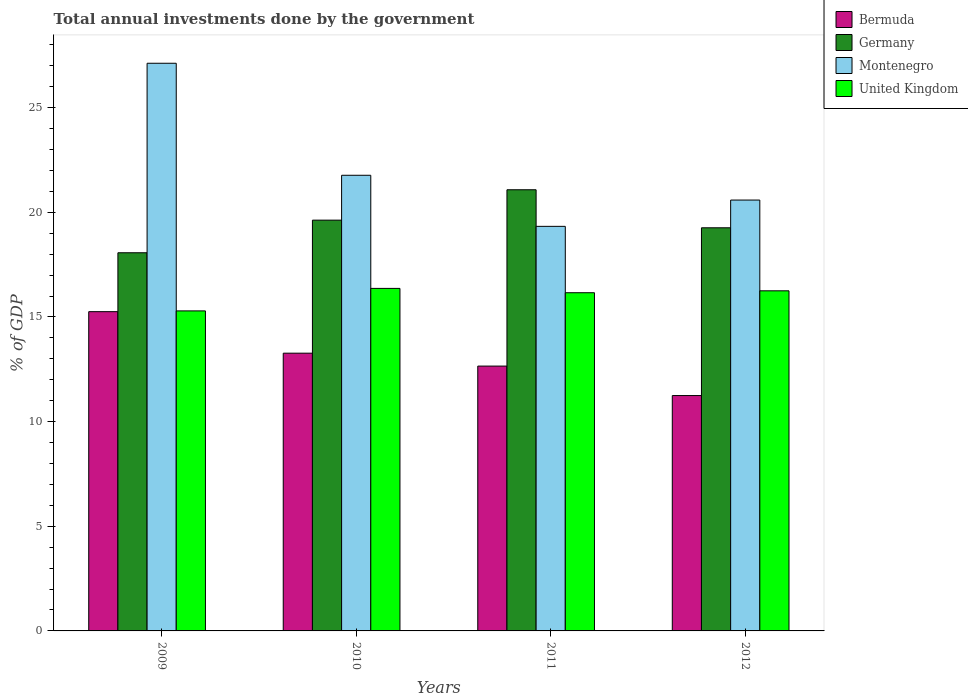How many different coloured bars are there?
Offer a very short reply. 4. How many groups of bars are there?
Provide a succinct answer. 4. Are the number of bars per tick equal to the number of legend labels?
Your response must be concise. Yes. Are the number of bars on each tick of the X-axis equal?
Ensure brevity in your answer.  Yes. How many bars are there on the 4th tick from the left?
Your response must be concise. 4. How many bars are there on the 1st tick from the right?
Your answer should be compact. 4. What is the label of the 2nd group of bars from the left?
Make the answer very short. 2010. In how many cases, is the number of bars for a given year not equal to the number of legend labels?
Keep it short and to the point. 0. What is the total annual investments done by the government in Bermuda in 2010?
Your answer should be very brief. 13.27. Across all years, what is the maximum total annual investments done by the government in Germany?
Your answer should be very brief. 21.08. Across all years, what is the minimum total annual investments done by the government in Montenegro?
Give a very brief answer. 19.33. In which year was the total annual investments done by the government in United Kingdom maximum?
Keep it short and to the point. 2010. In which year was the total annual investments done by the government in United Kingdom minimum?
Ensure brevity in your answer.  2009. What is the total total annual investments done by the government in Bermuda in the graph?
Your answer should be compact. 52.42. What is the difference between the total annual investments done by the government in Bermuda in 2010 and that in 2011?
Keep it short and to the point. 0.62. What is the difference between the total annual investments done by the government in Montenegro in 2010 and the total annual investments done by the government in United Kingdom in 2009?
Offer a very short reply. 6.48. What is the average total annual investments done by the government in United Kingdom per year?
Give a very brief answer. 16.02. In the year 2009, what is the difference between the total annual investments done by the government in Germany and total annual investments done by the government in Montenegro?
Your answer should be very brief. -9.05. What is the ratio of the total annual investments done by the government in Germany in 2010 to that in 2011?
Offer a very short reply. 0.93. What is the difference between the highest and the second highest total annual investments done by the government in Germany?
Make the answer very short. 1.45. What is the difference between the highest and the lowest total annual investments done by the government in United Kingdom?
Provide a succinct answer. 1.07. In how many years, is the total annual investments done by the government in Montenegro greater than the average total annual investments done by the government in Montenegro taken over all years?
Offer a terse response. 1. Is the sum of the total annual investments done by the government in Bermuda in 2011 and 2012 greater than the maximum total annual investments done by the government in Montenegro across all years?
Ensure brevity in your answer.  No. What does the 4th bar from the right in 2012 represents?
Make the answer very short. Bermuda. How many bars are there?
Keep it short and to the point. 16. Are all the bars in the graph horizontal?
Ensure brevity in your answer.  No. Are the values on the major ticks of Y-axis written in scientific E-notation?
Offer a terse response. No. Where does the legend appear in the graph?
Offer a terse response. Top right. What is the title of the graph?
Provide a succinct answer. Total annual investments done by the government. Does "Papua New Guinea" appear as one of the legend labels in the graph?
Make the answer very short. No. What is the label or title of the X-axis?
Offer a very short reply. Years. What is the label or title of the Y-axis?
Offer a very short reply. % of GDP. What is the % of GDP in Bermuda in 2009?
Offer a terse response. 15.25. What is the % of GDP in Germany in 2009?
Keep it short and to the point. 18.07. What is the % of GDP in Montenegro in 2009?
Provide a short and direct response. 27.12. What is the % of GDP of United Kingdom in 2009?
Make the answer very short. 15.29. What is the % of GDP of Bermuda in 2010?
Provide a short and direct response. 13.27. What is the % of GDP of Germany in 2010?
Your response must be concise. 19.63. What is the % of GDP in Montenegro in 2010?
Give a very brief answer. 21.77. What is the % of GDP of United Kingdom in 2010?
Your answer should be very brief. 16.36. What is the % of GDP of Bermuda in 2011?
Your answer should be very brief. 12.65. What is the % of GDP of Germany in 2011?
Give a very brief answer. 21.08. What is the % of GDP of Montenegro in 2011?
Give a very brief answer. 19.33. What is the % of GDP of United Kingdom in 2011?
Offer a terse response. 16.16. What is the % of GDP of Bermuda in 2012?
Your answer should be very brief. 11.25. What is the % of GDP in Germany in 2012?
Provide a succinct answer. 19.26. What is the % of GDP in Montenegro in 2012?
Ensure brevity in your answer.  20.59. What is the % of GDP of United Kingdom in 2012?
Give a very brief answer. 16.25. Across all years, what is the maximum % of GDP of Bermuda?
Give a very brief answer. 15.25. Across all years, what is the maximum % of GDP in Germany?
Provide a short and direct response. 21.08. Across all years, what is the maximum % of GDP in Montenegro?
Your response must be concise. 27.12. Across all years, what is the maximum % of GDP in United Kingdom?
Offer a terse response. 16.36. Across all years, what is the minimum % of GDP of Bermuda?
Provide a short and direct response. 11.25. Across all years, what is the minimum % of GDP in Germany?
Offer a terse response. 18.07. Across all years, what is the minimum % of GDP in Montenegro?
Your response must be concise. 19.33. Across all years, what is the minimum % of GDP in United Kingdom?
Provide a succinct answer. 15.29. What is the total % of GDP in Bermuda in the graph?
Your response must be concise. 52.42. What is the total % of GDP in Germany in the graph?
Provide a short and direct response. 78.03. What is the total % of GDP of Montenegro in the graph?
Offer a very short reply. 88.81. What is the total % of GDP in United Kingdom in the graph?
Provide a short and direct response. 64.06. What is the difference between the % of GDP of Bermuda in 2009 and that in 2010?
Offer a terse response. 1.98. What is the difference between the % of GDP of Germany in 2009 and that in 2010?
Your answer should be very brief. -1.56. What is the difference between the % of GDP in Montenegro in 2009 and that in 2010?
Your response must be concise. 5.35. What is the difference between the % of GDP in United Kingdom in 2009 and that in 2010?
Make the answer very short. -1.07. What is the difference between the % of GDP of Bermuda in 2009 and that in 2011?
Offer a terse response. 2.6. What is the difference between the % of GDP of Germany in 2009 and that in 2011?
Ensure brevity in your answer.  -3.01. What is the difference between the % of GDP in Montenegro in 2009 and that in 2011?
Make the answer very short. 7.79. What is the difference between the % of GDP in United Kingdom in 2009 and that in 2011?
Your answer should be very brief. -0.87. What is the difference between the % of GDP of Bermuda in 2009 and that in 2012?
Offer a very short reply. 4.01. What is the difference between the % of GDP of Germany in 2009 and that in 2012?
Your response must be concise. -1.19. What is the difference between the % of GDP in Montenegro in 2009 and that in 2012?
Offer a very short reply. 6.54. What is the difference between the % of GDP of United Kingdom in 2009 and that in 2012?
Keep it short and to the point. -0.96. What is the difference between the % of GDP of Bermuda in 2010 and that in 2011?
Your answer should be compact. 0.62. What is the difference between the % of GDP in Germany in 2010 and that in 2011?
Offer a terse response. -1.45. What is the difference between the % of GDP of Montenegro in 2010 and that in 2011?
Provide a short and direct response. 2.44. What is the difference between the % of GDP in United Kingdom in 2010 and that in 2011?
Give a very brief answer. 0.21. What is the difference between the % of GDP in Bermuda in 2010 and that in 2012?
Your answer should be very brief. 2.02. What is the difference between the % of GDP in Germany in 2010 and that in 2012?
Provide a succinct answer. 0.36. What is the difference between the % of GDP in Montenegro in 2010 and that in 2012?
Keep it short and to the point. 1.18. What is the difference between the % of GDP of United Kingdom in 2010 and that in 2012?
Your answer should be compact. 0.12. What is the difference between the % of GDP of Bermuda in 2011 and that in 2012?
Keep it short and to the point. 1.41. What is the difference between the % of GDP in Germany in 2011 and that in 2012?
Provide a short and direct response. 1.82. What is the difference between the % of GDP of Montenegro in 2011 and that in 2012?
Your response must be concise. -1.26. What is the difference between the % of GDP of United Kingdom in 2011 and that in 2012?
Provide a succinct answer. -0.09. What is the difference between the % of GDP of Bermuda in 2009 and the % of GDP of Germany in 2010?
Your answer should be compact. -4.37. What is the difference between the % of GDP in Bermuda in 2009 and the % of GDP in Montenegro in 2010?
Make the answer very short. -6.52. What is the difference between the % of GDP of Bermuda in 2009 and the % of GDP of United Kingdom in 2010?
Your answer should be very brief. -1.11. What is the difference between the % of GDP of Germany in 2009 and the % of GDP of Montenegro in 2010?
Offer a very short reply. -3.7. What is the difference between the % of GDP in Germany in 2009 and the % of GDP in United Kingdom in 2010?
Your answer should be very brief. 1.7. What is the difference between the % of GDP in Montenegro in 2009 and the % of GDP in United Kingdom in 2010?
Ensure brevity in your answer.  10.76. What is the difference between the % of GDP of Bermuda in 2009 and the % of GDP of Germany in 2011?
Provide a short and direct response. -5.82. What is the difference between the % of GDP of Bermuda in 2009 and the % of GDP of Montenegro in 2011?
Provide a short and direct response. -4.08. What is the difference between the % of GDP in Bermuda in 2009 and the % of GDP in United Kingdom in 2011?
Make the answer very short. -0.9. What is the difference between the % of GDP of Germany in 2009 and the % of GDP of Montenegro in 2011?
Offer a terse response. -1.26. What is the difference between the % of GDP of Germany in 2009 and the % of GDP of United Kingdom in 2011?
Your answer should be compact. 1.91. What is the difference between the % of GDP in Montenegro in 2009 and the % of GDP in United Kingdom in 2011?
Ensure brevity in your answer.  10.96. What is the difference between the % of GDP in Bermuda in 2009 and the % of GDP in Germany in 2012?
Your answer should be very brief. -4.01. What is the difference between the % of GDP of Bermuda in 2009 and the % of GDP of Montenegro in 2012?
Offer a terse response. -5.33. What is the difference between the % of GDP in Bermuda in 2009 and the % of GDP in United Kingdom in 2012?
Your answer should be very brief. -1. What is the difference between the % of GDP of Germany in 2009 and the % of GDP of Montenegro in 2012?
Give a very brief answer. -2.52. What is the difference between the % of GDP of Germany in 2009 and the % of GDP of United Kingdom in 2012?
Offer a terse response. 1.82. What is the difference between the % of GDP in Montenegro in 2009 and the % of GDP in United Kingdom in 2012?
Your answer should be compact. 10.87. What is the difference between the % of GDP of Bermuda in 2010 and the % of GDP of Germany in 2011?
Make the answer very short. -7.81. What is the difference between the % of GDP of Bermuda in 2010 and the % of GDP of Montenegro in 2011?
Provide a succinct answer. -6.06. What is the difference between the % of GDP of Bermuda in 2010 and the % of GDP of United Kingdom in 2011?
Make the answer very short. -2.89. What is the difference between the % of GDP of Germany in 2010 and the % of GDP of Montenegro in 2011?
Provide a succinct answer. 0.3. What is the difference between the % of GDP of Germany in 2010 and the % of GDP of United Kingdom in 2011?
Your answer should be compact. 3.47. What is the difference between the % of GDP in Montenegro in 2010 and the % of GDP in United Kingdom in 2011?
Offer a very short reply. 5.61. What is the difference between the % of GDP of Bermuda in 2010 and the % of GDP of Germany in 2012?
Offer a very short reply. -5.99. What is the difference between the % of GDP in Bermuda in 2010 and the % of GDP in Montenegro in 2012?
Ensure brevity in your answer.  -7.32. What is the difference between the % of GDP in Bermuda in 2010 and the % of GDP in United Kingdom in 2012?
Keep it short and to the point. -2.98. What is the difference between the % of GDP in Germany in 2010 and the % of GDP in Montenegro in 2012?
Provide a short and direct response. -0.96. What is the difference between the % of GDP of Germany in 2010 and the % of GDP of United Kingdom in 2012?
Provide a short and direct response. 3.38. What is the difference between the % of GDP of Montenegro in 2010 and the % of GDP of United Kingdom in 2012?
Ensure brevity in your answer.  5.52. What is the difference between the % of GDP in Bermuda in 2011 and the % of GDP in Germany in 2012?
Offer a very short reply. -6.61. What is the difference between the % of GDP of Bermuda in 2011 and the % of GDP of Montenegro in 2012?
Make the answer very short. -7.93. What is the difference between the % of GDP in Bermuda in 2011 and the % of GDP in United Kingdom in 2012?
Provide a short and direct response. -3.6. What is the difference between the % of GDP in Germany in 2011 and the % of GDP in Montenegro in 2012?
Offer a terse response. 0.49. What is the difference between the % of GDP in Germany in 2011 and the % of GDP in United Kingdom in 2012?
Give a very brief answer. 4.83. What is the difference between the % of GDP in Montenegro in 2011 and the % of GDP in United Kingdom in 2012?
Your answer should be very brief. 3.08. What is the average % of GDP in Bermuda per year?
Make the answer very short. 13.11. What is the average % of GDP of Germany per year?
Keep it short and to the point. 19.51. What is the average % of GDP of Montenegro per year?
Your answer should be compact. 22.2. What is the average % of GDP of United Kingdom per year?
Ensure brevity in your answer.  16.02. In the year 2009, what is the difference between the % of GDP in Bermuda and % of GDP in Germany?
Give a very brief answer. -2.81. In the year 2009, what is the difference between the % of GDP in Bermuda and % of GDP in Montenegro?
Make the answer very short. -11.87. In the year 2009, what is the difference between the % of GDP of Bermuda and % of GDP of United Kingdom?
Keep it short and to the point. -0.04. In the year 2009, what is the difference between the % of GDP of Germany and % of GDP of Montenegro?
Offer a very short reply. -9.05. In the year 2009, what is the difference between the % of GDP in Germany and % of GDP in United Kingdom?
Your answer should be very brief. 2.78. In the year 2009, what is the difference between the % of GDP in Montenegro and % of GDP in United Kingdom?
Your response must be concise. 11.83. In the year 2010, what is the difference between the % of GDP of Bermuda and % of GDP of Germany?
Keep it short and to the point. -6.36. In the year 2010, what is the difference between the % of GDP of Bermuda and % of GDP of Montenegro?
Your answer should be compact. -8.5. In the year 2010, what is the difference between the % of GDP in Bermuda and % of GDP in United Kingdom?
Your response must be concise. -3.1. In the year 2010, what is the difference between the % of GDP of Germany and % of GDP of Montenegro?
Offer a very short reply. -2.14. In the year 2010, what is the difference between the % of GDP of Germany and % of GDP of United Kingdom?
Your answer should be compact. 3.26. In the year 2010, what is the difference between the % of GDP of Montenegro and % of GDP of United Kingdom?
Your answer should be very brief. 5.41. In the year 2011, what is the difference between the % of GDP in Bermuda and % of GDP in Germany?
Your answer should be compact. -8.42. In the year 2011, what is the difference between the % of GDP of Bermuda and % of GDP of Montenegro?
Offer a terse response. -6.68. In the year 2011, what is the difference between the % of GDP of Bermuda and % of GDP of United Kingdom?
Your answer should be very brief. -3.5. In the year 2011, what is the difference between the % of GDP of Germany and % of GDP of Montenegro?
Provide a short and direct response. 1.75. In the year 2011, what is the difference between the % of GDP in Germany and % of GDP in United Kingdom?
Your response must be concise. 4.92. In the year 2011, what is the difference between the % of GDP of Montenegro and % of GDP of United Kingdom?
Your answer should be compact. 3.17. In the year 2012, what is the difference between the % of GDP of Bermuda and % of GDP of Germany?
Your response must be concise. -8.02. In the year 2012, what is the difference between the % of GDP in Bermuda and % of GDP in Montenegro?
Offer a very short reply. -9.34. In the year 2012, what is the difference between the % of GDP of Bermuda and % of GDP of United Kingdom?
Your answer should be compact. -5. In the year 2012, what is the difference between the % of GDP in Germany and % of GDP in Montenegro?
Provide a succinct answer. -1.33. In the year 2012, what is the difference between the % of GDP of Germany and % of GDP of United Kingdom?
Your answer should be very brief. 3.01. In the year 2012, what is the difference between the % of GDP of Montenegro and % of GDP of United Kingdom?
Offer a terse response. 4.34. What is the ratio of the % of GDP in Bermuda in 2009 to that in 2010?
Offer a terse response. 1.15. What is the ratio of the % of GDP of Germany in 2009 to that in 2010?
Provide a succinct answer. 0.92. What is the ratio of the % of GDP of Montenegro in 2009 to that in 2010?
Make the answer very short. 1.25. What is the ratio of the % of GDP of United Kingdom in 2009 to that in 2010?
Keep it short and to the point. 0.93. What is the ratio of the % of GDP of Bermuda in 2009 to that in 2011?
Give a very brief answer. 1.21. What is the ratio of the % of GDP of Germany in 2009 to that in 2011?
Offer a very short reply. 0.86. What is the ratio of the % of GDP of Montenegro in 2009 to that in 2011?
Provide a short and direct response. 1.4. What is the ratio of the % of GDP in United Kingdom in 2009 to that in 2011?
Your response must be concise. 0.95. What is the ratio of the % of GDP of Bermuda in 2009 to that in 2012?
Your response must be concise. 1.36. What is the ratio of the % of GDP of Germany in 2009 to that in 2012?
Provide a succinct answer. 0.94. What is the ratio of the % of GDP in Montenegro in 2009 to that in 2012?
Give a very brief answer. 1.32. What is the ratio of the % of GDP in United Kingdom in 2009 to that in 2012?
Give a very brief answer. 0.94. What is the ratio of the % of GDP of Bermuda in 2010 to that in 2011?
Ensure brevity in your answer.  1.05. What is the ratio of the % of GDP in Germany in 2010 to that in 2011?
Your response must be concise. 0.93. What is the ratio of the % of GDP of Montenegro in 2010 to that in 2011?
Provide a short and direct response. 1.13. What is the ratio of the % of GDP of United Kingdom in 2010 to that in 2011?
Provide a succinct answer. 1.01. What is the ratio of the % of GDP in Bermuda in 2010 to that in 2012?
Your answer should be compact. 1.18. What is the ratio of the % of GDP in Germany in 2010 to that in 2012?
Make the answer very short. 1.02. What is the ratio of the % of GDP of Montenegro in 2010 to that in 2012?
Offer a very short reply. 1.06. What is the ratio of the % of GDP in United Kingdom in 2010 to that in 2012?
Make the answer very short. 1.01. What is the ratio of the % of GDP in Bermuda in 2011 to that in 2012?
Provide a succinct answer. 1.13. What is the ratio of the % of GDP of Germany in 2011 to that in 2012?
Keep it short and to the point. 1.09. What is the ratio of the % of GDP of Montenegro in 2011 to that in 2012?
Offer a terse response. 0.94. What is the ratio of the % of GDP of United Kingdom in 2011 to that in 2012?
Offer a terse response. 0.99. What is the difference between the highest and the second highest % of GDP in Bermuda?
Give a very brief answer. 1.98. What is the difference between the highest and the second highest % of GDP in Germany?
Offer a terse response. 1.45. What is the difference between the highest and the second highest % of GDP of Montenegro?
Offer a very short reply. 5.35. What is the difference between the highest and the second highest % of GDP of United Kingdom?
Offer a terse response. 0.12. What is the difference between the highest and the lowest % of GDP of Bermuda?
Ensure brevity in your answer.  4.01. What is the difference between the highest and the lowest % of GDP in Germany?
Give a very brief answer. 3.01. What is the difference between the highest and the lowest % of GDP in Montenegro?
Provide a succinct answer. 7.79. What is the difference between the highest and the lowest % of GDP of United Kingdom?
Offer a terse response. 1.07. 